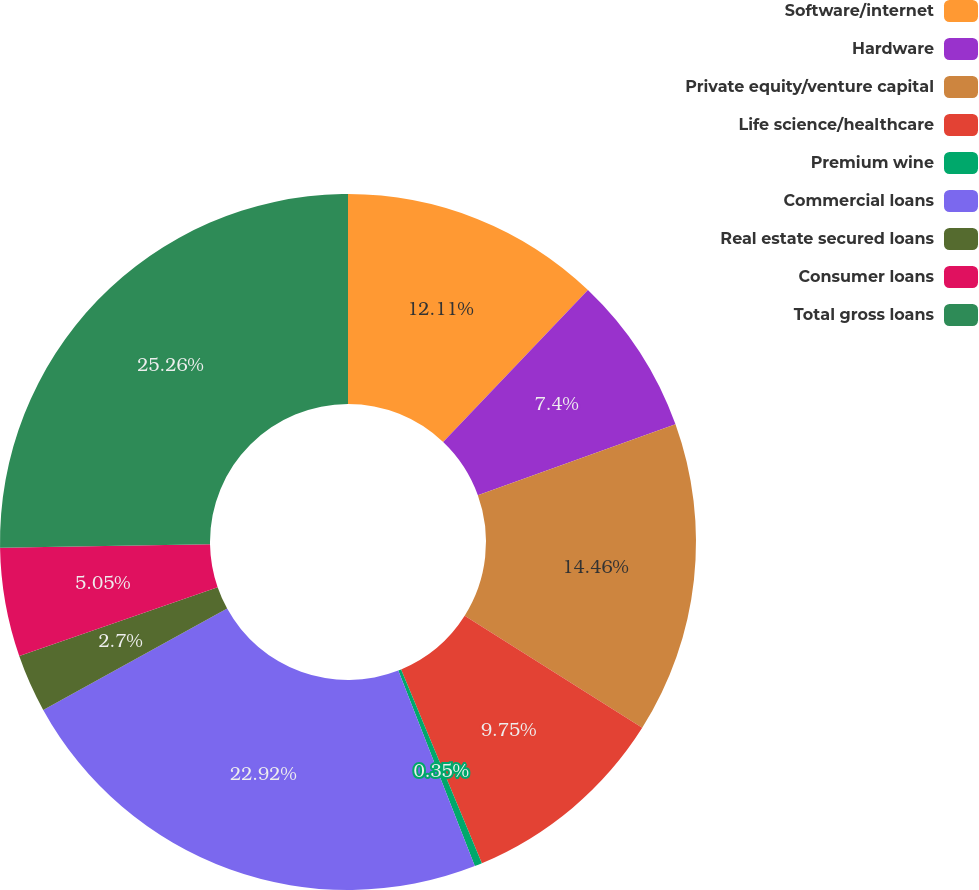Convert chart to OTSL. <chart><loc_0><loc_0><loc_500><loc_500><pie_chart><fcel>Software/internet<fcel>Hardware<fcel>Private equity/venture capital<fcel>Life science/healthcare<fcel>Premium wine<fcel>Commercial loans<fcel>Real estate secured loans<fcel>Consumer loans<fcel>Total gross loans<nl><fcel>12.11%<fcel>7.4%<fcel>14.46%<fcel>9.75%<fcel>0.35%<fcel>22.92%<fcel>2.7%<fcel>5.05%<fcel>25.27%<nl></chart> 